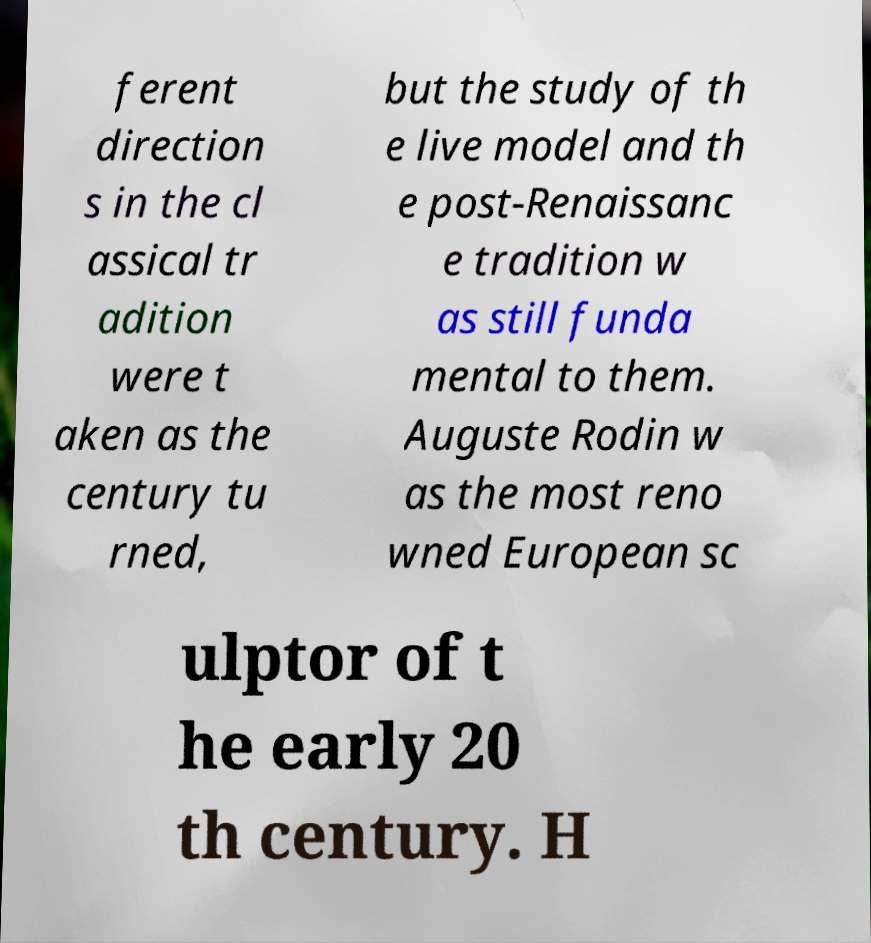I need the written content from this picture converted into text. Can you do that? ferent direction s in the cl assical tr adition were t aken as the century tu rned, but the study of th e live model and th e post-Renaissanc e tradition w as still funda mental to them. Auguste Rodin w as the most reno wned European sc ulptor of t he early 20 th century. H 